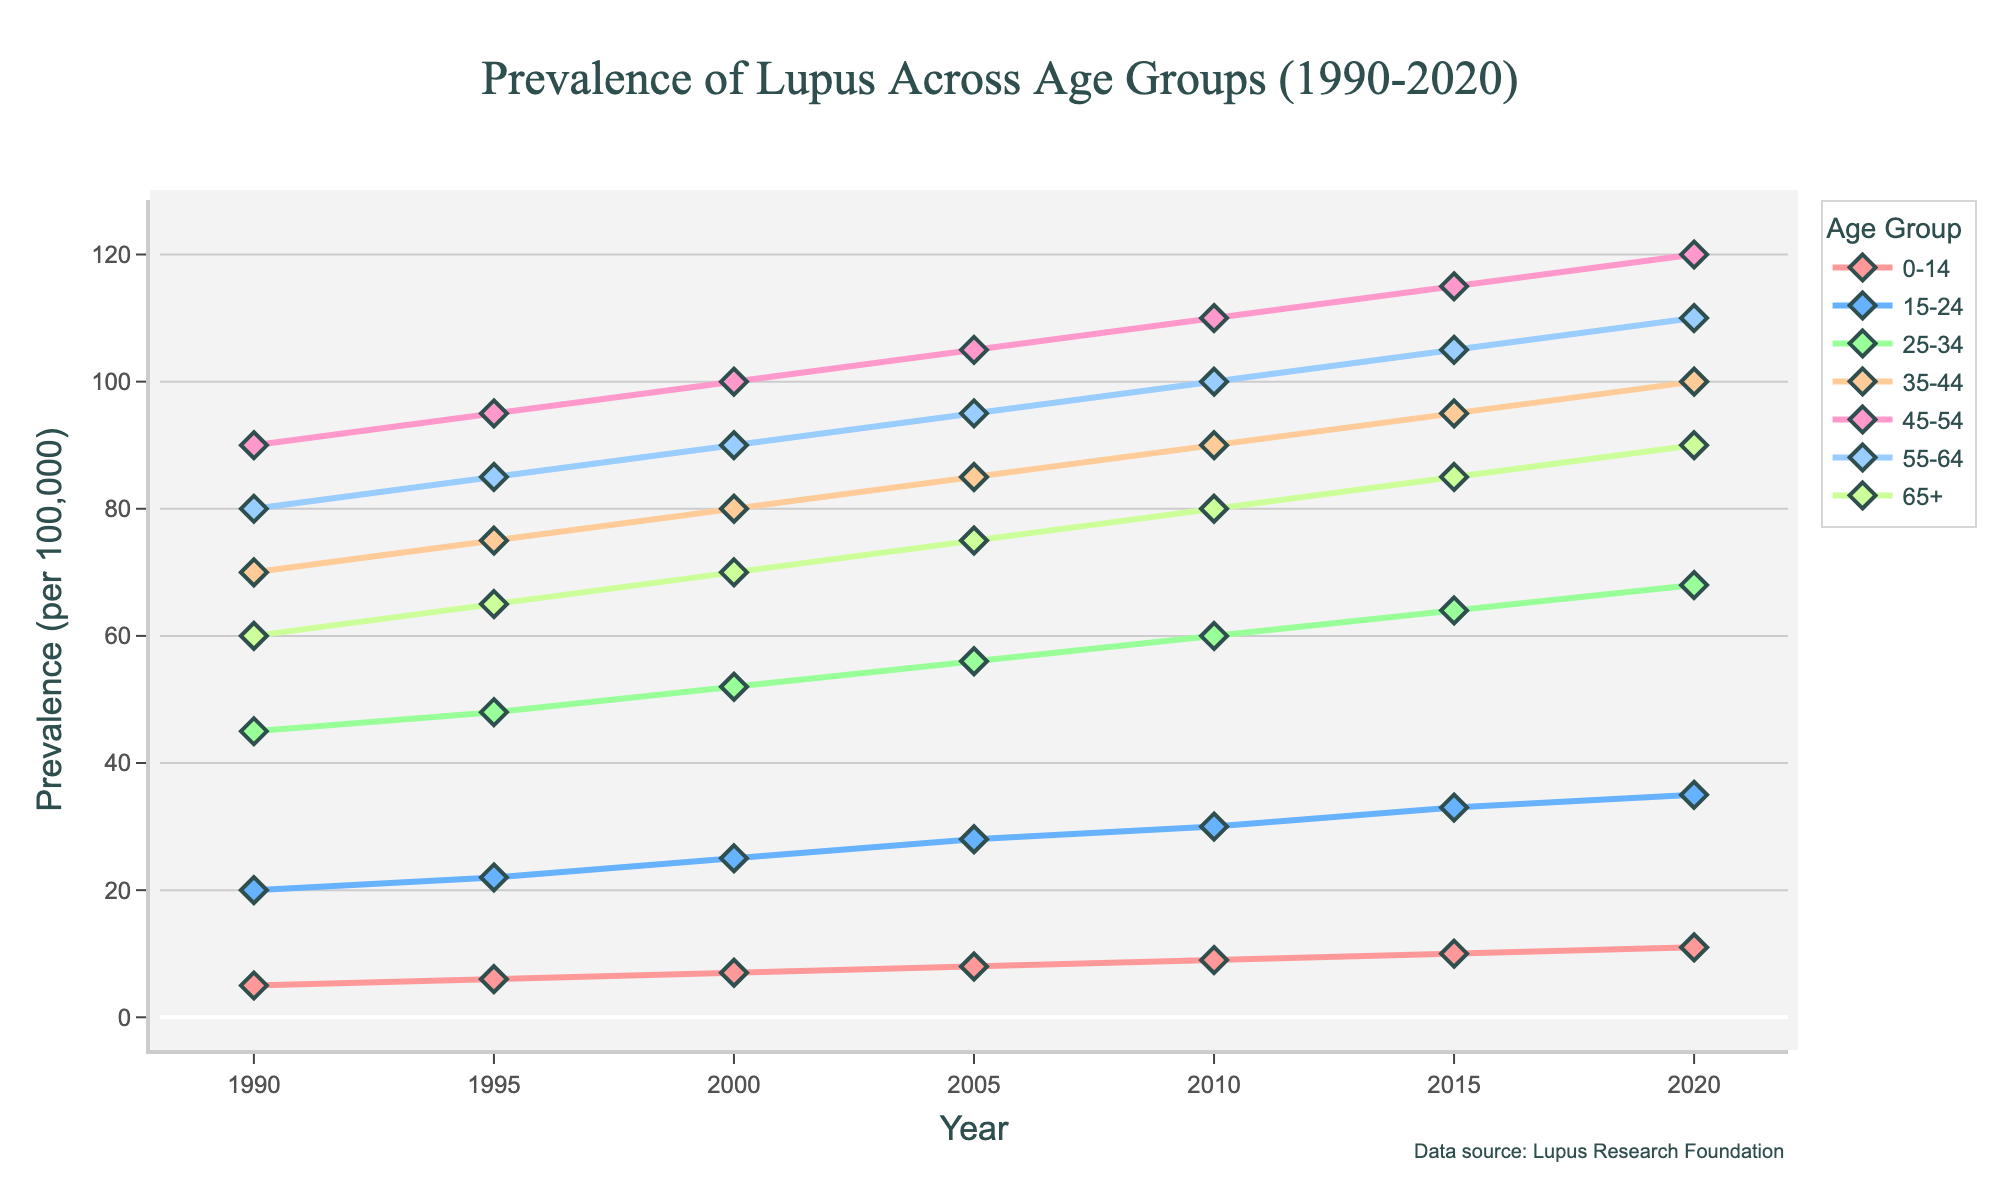Which age group had the highest prevalence of lupus in 2020? The highest line represents the prevalence in the 45-54 age group, which reaches up to 120 in 2020.
Answer: 45-54 How does the prevalence of lupus in the 25-34 age group in 2000 compare to the 35-44 age group in the same year? In 2000, the prevalence is 52 for the 25-34 age group and 80 for the 35-44 age group. Comparing these, 52 is less than 80.
Answer: Less than Which age group saw the largest increase in the prevalence of lupus from 1990 to 2020? Calculate the difference between prevalence in 2020 and 1990 for all age groups: 0-14: 11-5=6, 15-24: 35-20=15, 25-34: 68-45=23, 35-44: 100-70=30, 45-54: 120-90=30, 55-64: 110-80=30, 65+: 90-60=30. All groups had a maximum increase of 30.
Answer: 35-44, 45-54, 55-64, 65+ What was the average prevalence of lupus across all age groups in 2015? Sum all the prevalence values in 2015 and divide by the number of age groups: (10 + 33 + 64 + 95 + 115 + 105 + 85) / 7 = 507 / 7 ≈ 72.43
Answer: 72.43 Is the prevalence trend for the 0-14 age group increasing, decreasing, or stable from 1990 to 2020? From the line graph for the 0-14 age group, the line consistently moves upwards from 5 to 11, indicating an increasing trend.
Answer: Increasing Which age group had a prevalence of lupus closest to 70 in the year 2000? Checking the values for 2000 for each age group, the 25-34 age group had a prevalence of 52, and the 35-44 age group had 80. 80 is closer to 70.
Answer: 35-44 Compare the prevalence trend of lupus for the 15-24 age group versus the 55-64 age group from 2005 to 2020. Both trends increase, but the 15-24 age group increases from 28 to 35 while the 55-64 age group increases from 95 to 110. The 55-64 age group shows a larger increase overall.
Answer: 55-64 had a larger increase What is the total increase in prevalence for the age group 15-24 from 1990 to 2020? Subtract the 1990 value from the 2020 value for the 15-24 age group: 35 - 20 = 15.
Answer: 15 Between 1990 and 2020, which age groups have shown a steady increase in lupus prevalence without any decline? Inspecting each line visually, every age group's prevalence consistently increased or remained steady without decline over the years shown.
Answer: All age groups What is the difference in prevalence between the 35-44 and 65+ age groups in 2010? The prevalence in 2010 for 35-44 is 90, and for 65+ it is 80. The difference is 90 - 80 = 10.
Answer: 10 